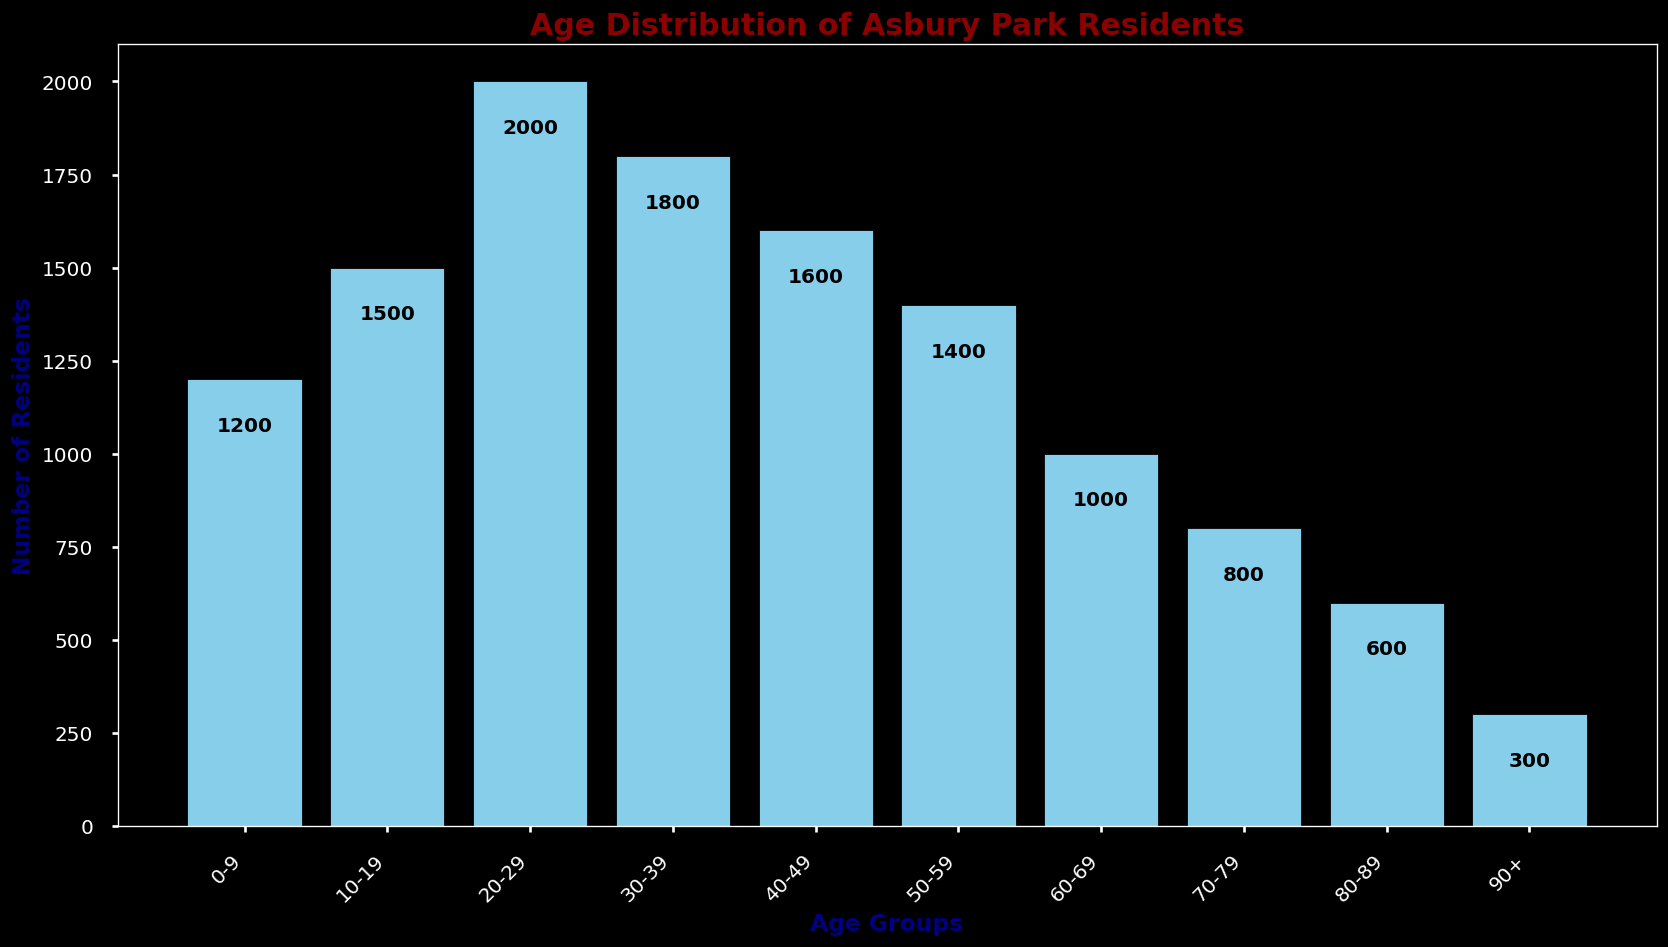Which age group has the highest number of residents? The histogram shows that the 20-29 age group has the tallest bar, indicating this age group has the highest number of residents.
Answer: 20-29 Which age group has the lowest number of residents? The histogram shows that the 90+ age group has the shortest bar, indicating this age group has the lowest number of residents.
Answer: 90+ What's the total number of residents aged between 30 to 59 years? Add the counts for the 30-39, 40-49, and 50-59 age groups: 1800 (30-39) + 1600 (40-49) + 1400 (50-59) = 4800
Answer: 4800 How many more residents are there in the 20-29 age group than in the 70-79 age group? Subtract the number of residents in the 70-79 age group from those in the 20-29 age group: 2000 (20-29) - 800 (70-79) = 1200
Answer: 1200 Is the number of residents in the 40-49 age group greater than in the 60-69 age group? Compare the counts for the 40-49 and 60-69 age groups: 1600 (40-49) is greater than 1000 (60-69).
Answer: Yes What's the average number of residents in the 0-9 and 10-19 age groups? Add the counts for the 0-9 and 10-19 age groups and divide by 2: (1200 (0-9) + 1500 (10-19)) / 2 = 1350
Answer: 1350 Which has more residents: the combined 0-9 and 80-89 age groups or the 30-39 age group alone? Add the counts for the 0-9 and 80-89 age groups and compare to the 30-39 age group: 1200 (0-9) + 600 (80-89) = 1800. This is equal to the 1800 residents in the 30-39 age group.
Answer: They are equal Are there more residents over 60 years old or under 20 years old? Calculate the sum of residents over 60 and under 20 and compare: Over 60: 1000 (60-69) + 800 (70-79) + 600 (80-89) + 300 (90+) = 2700; Under 20: 1200 (0-9) + 1500 (10-19) = 2700.
Answer: They are equal Which interval shows a noticeable decrease in the number of residents compared to the previous age group? Noticeable decrease is seen from 50-59 (1400) to 60-69 (1000), a difference of 400.
Answer: From 50-59 to 60-69 